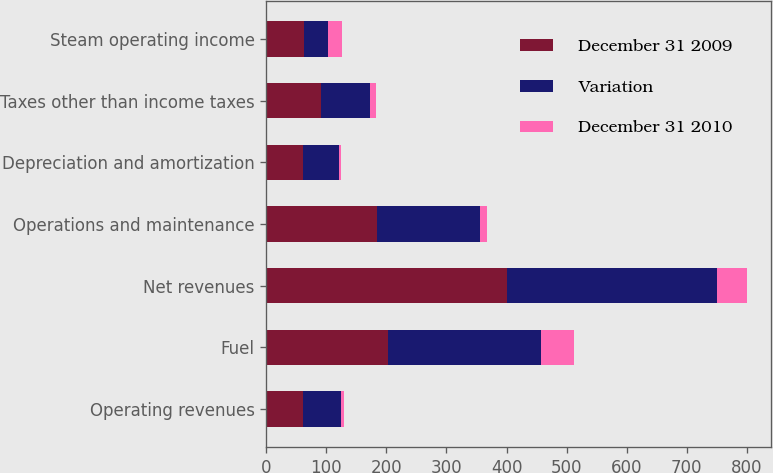<chart> <loc_0><loc_0><loc_500><loc_500><stacked_bar_chart><ecel><fcel>Operating revenues<fcel>Fuel<fcel>Net revenues<fcel>Operations and maintenance<fcel>Depreciation and amortization<fcel>Taxes other than income taxes<fcel>Steam operating income<nl><fcel>December 31 2009<fcel>62<fcel>202<fcel>400<fcel>184<fcel>62<fcel>91<fcel>63<nl><fcel>Variation<fcel>62<fcel>256<fcel>351<fcel>171<fcel>59<fcel>82<fcel>39<nl><fcel>December 31 2010<fcel>5<fcel>54<fcel>49<fcel>13<fcel>3<fcel>9<fcel>24<nl></chart> 